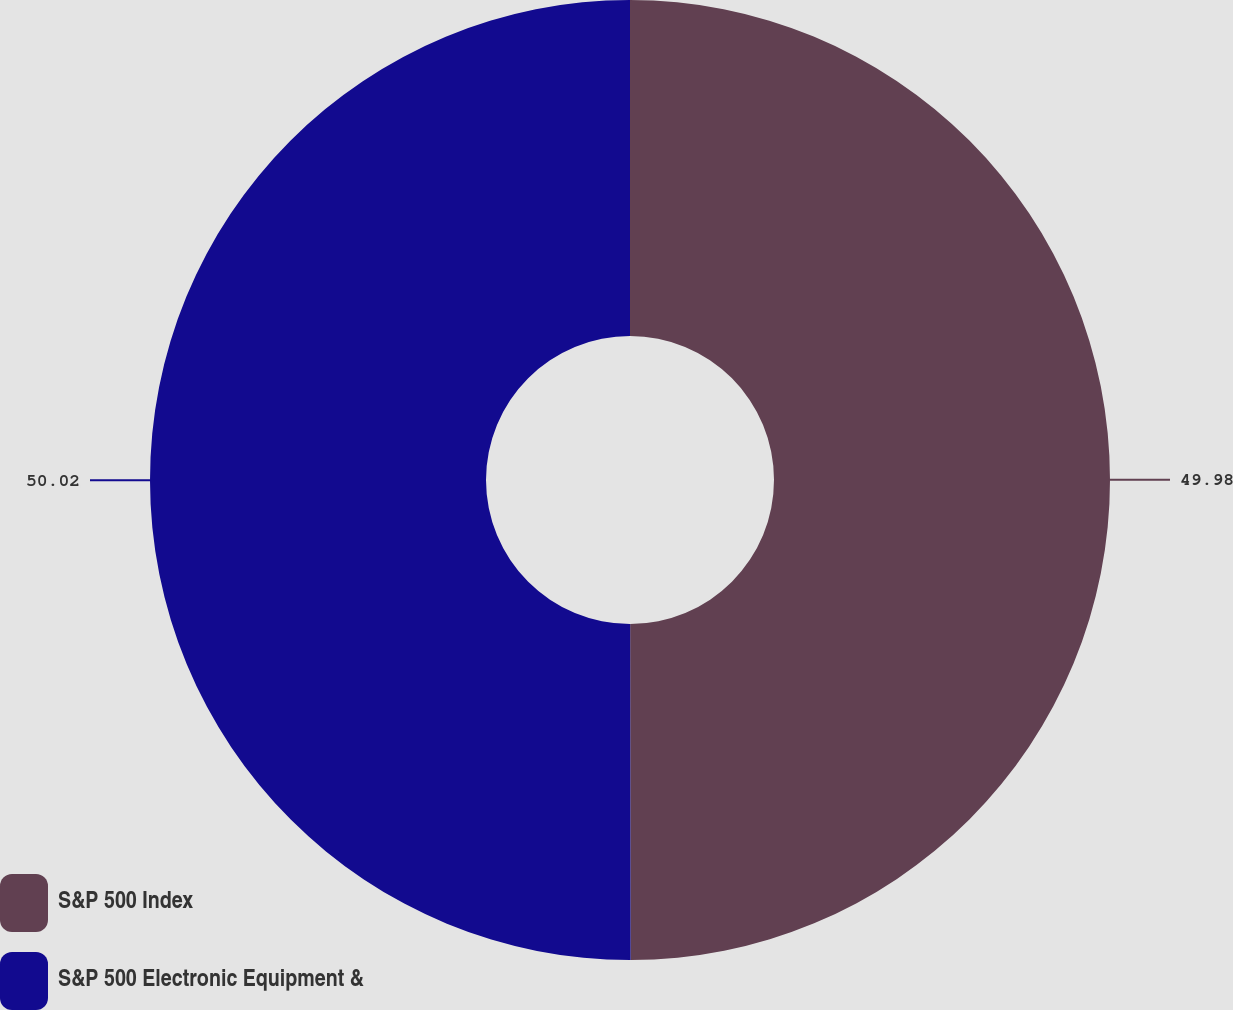<chart> <loc_0><loc_0><loc_500><loc_500><pie_chart><fcel>S&P 500 Index<fcel>S&P 500 Electronic Equipment &<nl><fcel>49.98%<fcel>50.02%<nl></chart> 